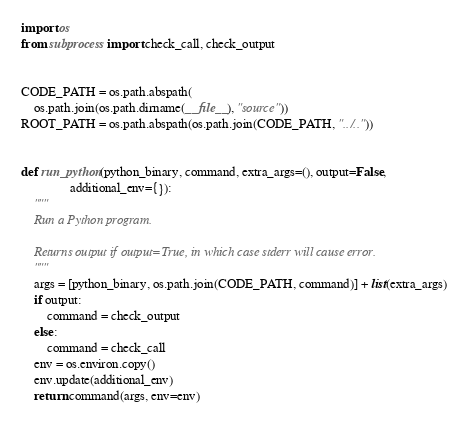<code> <loc_0><loc_0><loc_500><loc_500><_Python_>import os
from subprocess import check_call, check_output


CODE_PATH = os.path.abspath(
    os.path.join(os.path.dirname(__file__), "source"))
ROOT_PATH = os.path.abspath(os.path.join(CODE_PATH, "../.."))


def run_python(python_binary, command, extra_args=(), output=False,
               additional_env={}):
    """
    Run a Python program.

    Returns output if output=True, in which case stderr will cause error.
    """
    args = [python_binary, os.path.join(CODE_PATH, command)] + list(extra_args)
    if output:
        command = check_output
    else:
        command = check_call
    env = os.environ.copy()
    env.update(additional_env)
    return command(args, env=env)
</code> 